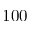<formula> <loc_0><loc_0><loc_500><loc_500>1 0 0</formula> 